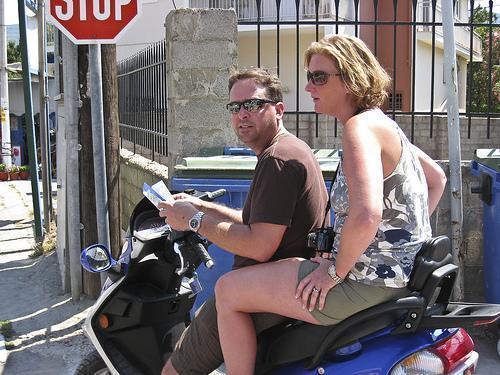How many people are present in this picutre?
Give a very brief answer. 2. 